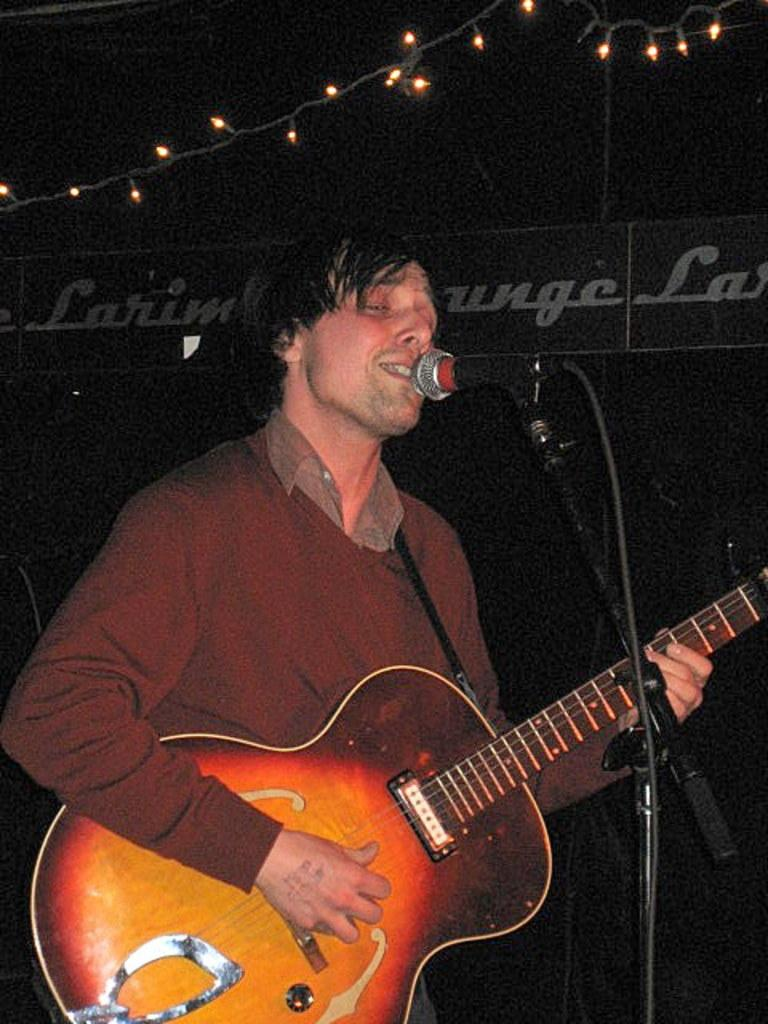What is the man in the image doing? The man is playing a guitar and singing. What is the man wearing in the image? The man is wearing a brown t-shirt. What instrument is the man playing in the image? The man is playing a guitar. What is the color of the guitar in the image? The guitar has a red and orange shade. What is the man standing in front of in the image? The man is in front of a microphone. What can be seen in the background of the image? There are lights visible in the image. How many sheets of paper are on the floor in the image? There are no sheets of paper visible in the image. What type of anger is the man expressing in the image? The image does not show any indication of anger; the man is playing a guitar and singing. 